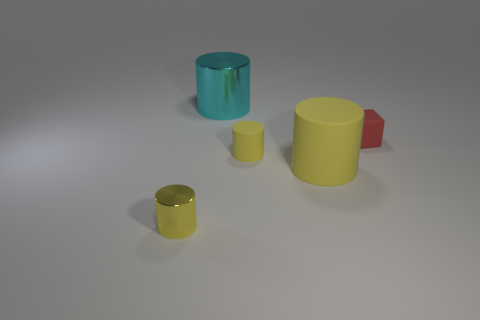Subtract all yellow cylinders. How many were subtracted if there are1yellow cylinders left? 2 Subtract all yellow cubes. How many yellow cylinders are left? 3 Add 5 large blue metallic things. How many objects exist? 10 Subtract all cylinders. How many objects are left? 1 Add 3 red rubber cubes. How many red rubber cubes are left? 4 Add 4 big blue balls. How many big blue balls exist? 4 Subtract 0 red cylinders. How many objects are left? 5 Subtract all big matte cubes. Subtract all tiny cylinders. How many objects are left? 3 